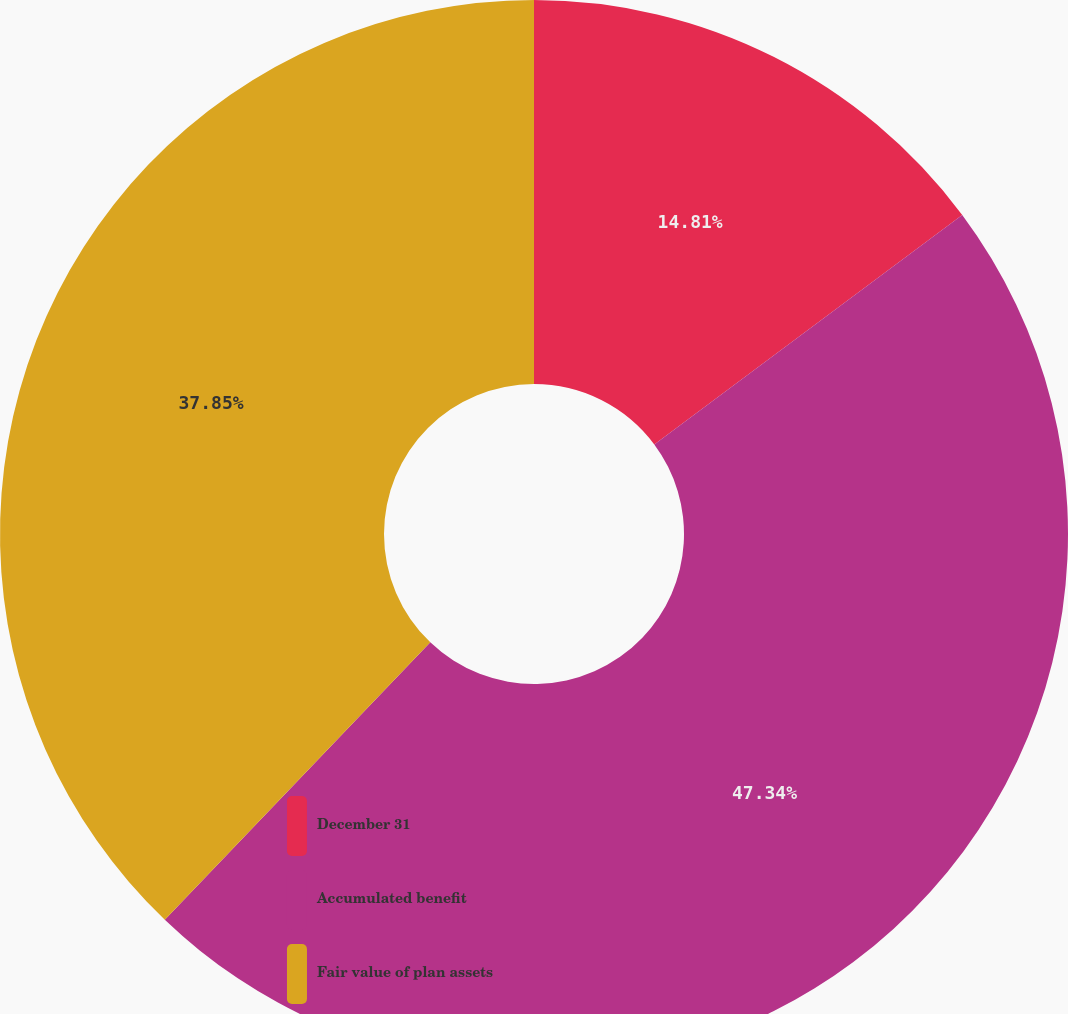Convert chart to OTSL. <chart><loc_0><loc_0><loc_500><loc_500><pie_chart><fcel>December 31<fcel>Accumulated benefit<fcel>Fair value of plan assets<nl><fcel>14.81%<fcel>47.34%<fcel>37.85%<nl></chart> 